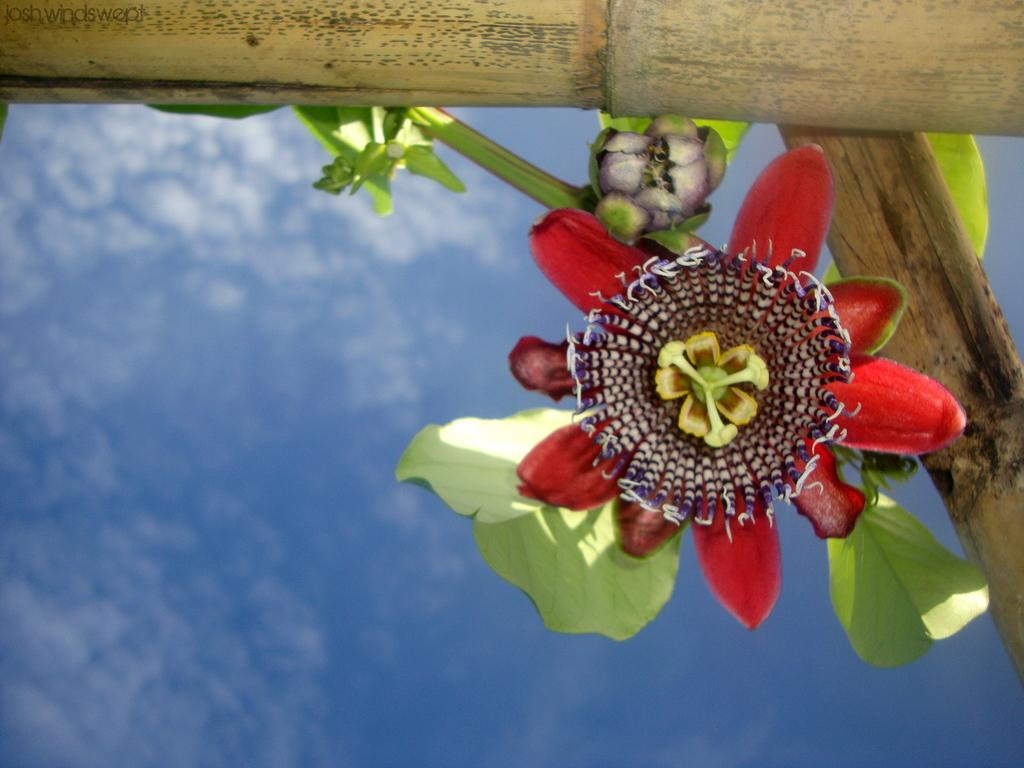What type of objects are made of wood in the image? There are wooden poles in the image. What type of plant is visible in the image? There is a plant in the image. What additional features can be seen on the plant? There are flowers in the image. What is visible in the background of the image? The sky is visible in the image, and clouds are present in the sky. Is there a test being conducted on the flowers in the image? There is no indication of a test being conducted in the image; it simply shows a plant with flowers. Can you see a swing in the image? There is no swing present in the image. 